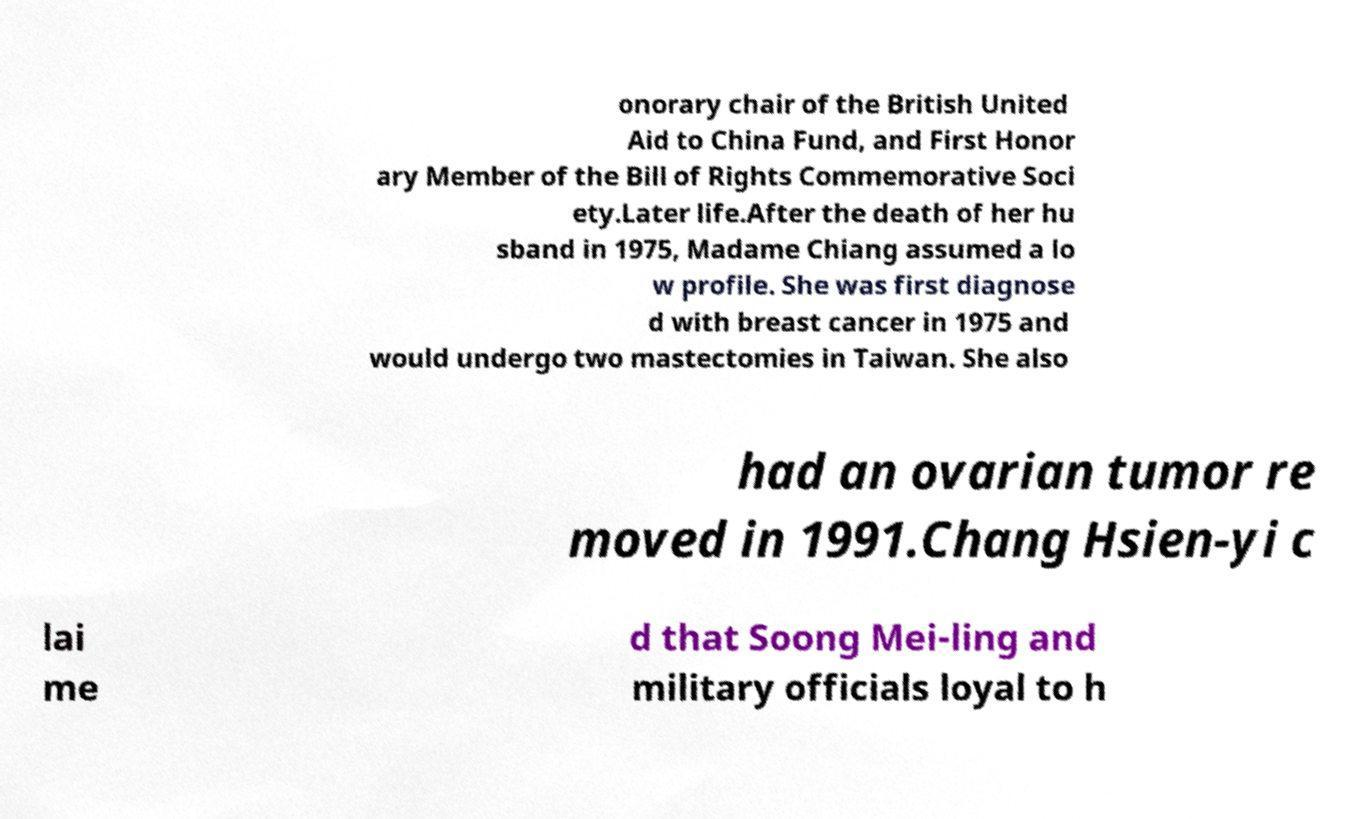There's text embedded in this image that I need extracted. Can you transcribe it verbatim? onorary chair of the British United Aid to China Fund, and First Honor ary Member of the Bill of Rights Commemorative Soci ety.Later life.After the death of her hu sband in 1975, Madame Chiang assumed a lo w profile. She was first diagnose d with breast cancer in 1975 and would undergo two mastectomies in Taiwan. She also had an ovarian tumor re moved in 1991.Chang Hsien-yi c lai me d that Soong Mei-ling and military officials loyal to h 